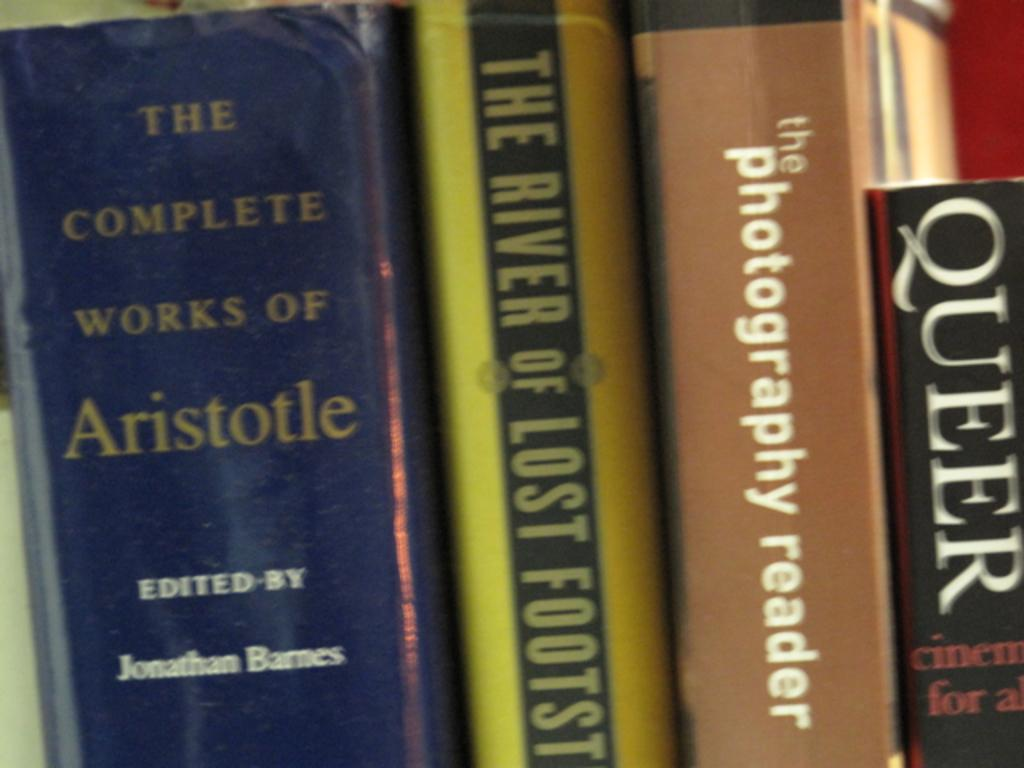<image>
Render a clear and concise summary of the photo. A various work of arts, books from Queer to Aristotle. 